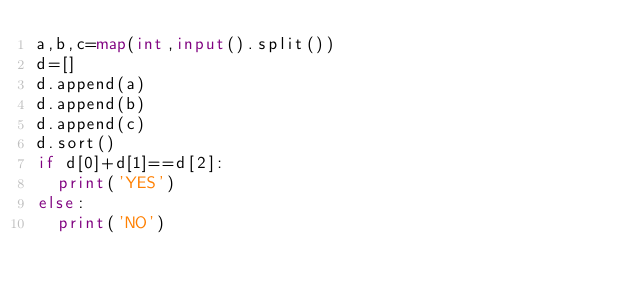Convert code to text. <code><loc_0><loc_0><loc_500><loc_500><_Python_>a,b,c=map(int,input().split())
d=[]
d.append(a)
d.append(b)
d.append(c)
d.sort()
if d[0]+d[1]==d[2]:
  print('YES')
else:
  print('NO')
</code> 